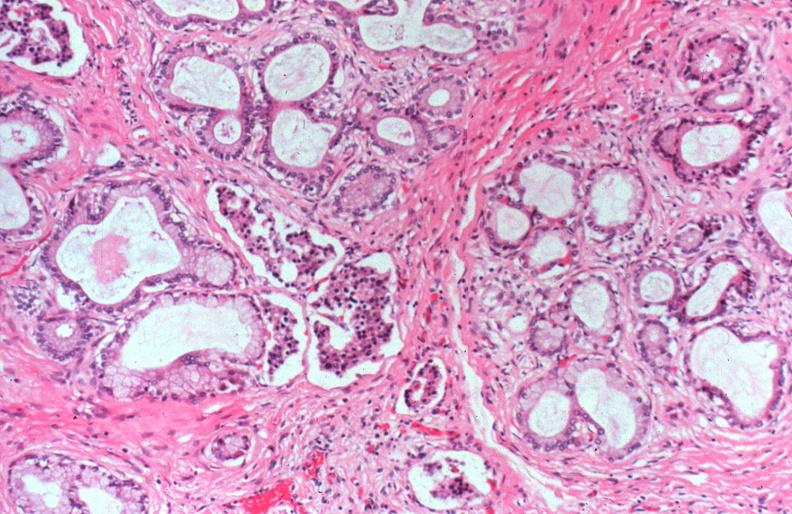s pancreas present?
Answer the question using a single word or phrase. Yes 